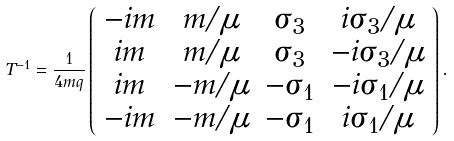<formula> <loc_0><loc_0><loc_500><loc_500>T ^ { - 1 } = \frac { 1 } { 4 m q } \left ( \begin{array} { c c c c } - i m & m / \mu & \sigma _ { 3 } & i \sigma _ { 3 } / \mu \\ i m & m / \mu & \sigma _ { 3 } & - i \sigma _ { 3 } / \mu \\ i m & - m / \mu & - \sigma _ { 1 } & - i \sigma _ { 1 } / \mu \\ - i m & - m / \mu & - \sigma _ { 1 } & i \sigma _ { 1 } / \mu \end{array} \right ) .</formula> 